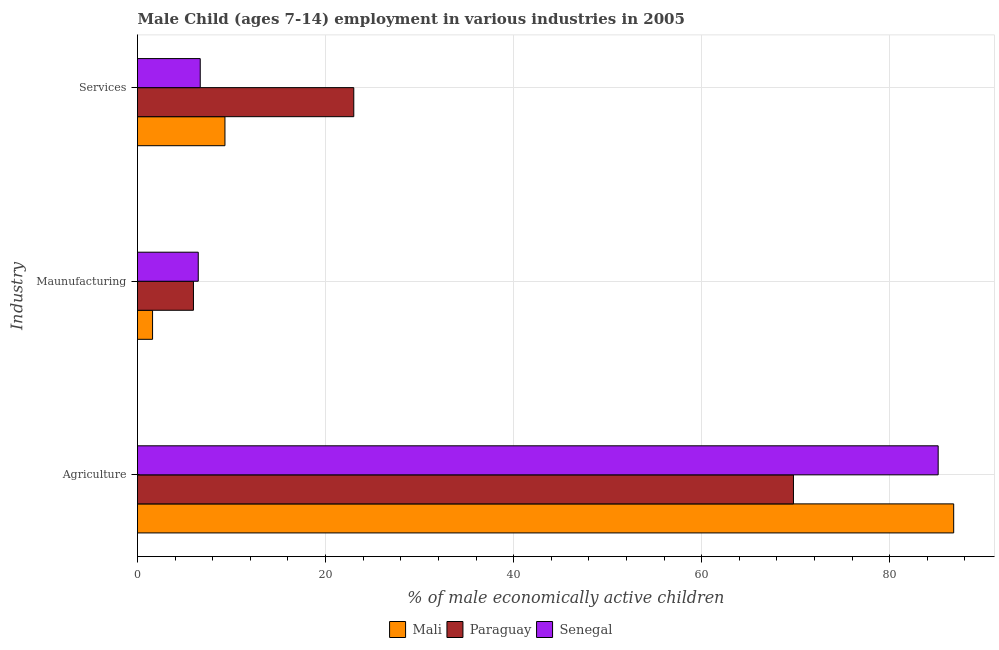Are the number of bars on each tick of the Y-axis equal?
Make the answer very short. Yes. How many bars are there on the 1st tick from the bottom?
Your answer should be compact. 3. What is the label of the 3rd group of bars from the top?
Keep it short and to the point. Agriculture. What is the percentage of economically active children in agriculture in Paraguay?
Your answer should be very brief. 69.76. Across all countries, what is the maximum percentage of economically active children in manufacturing?
Offer a very short reply. 6.46. Across all countries, what is the minimum percentage of economically active children in manufacturing?
Give a very brief answer. 1.6. In which country was the percentage of economically active children in services maximum?
Provide a succinct answer. Paraguay. In which country was the percentage of economically active children in services minimum?
Provide a short and direct response. Senegal. What is the total percentage of economically active children in agriculture in the graph?
Provide a succinct answer. 241.71. What is the difference between the percentage of economically active children in services in Mali and that in Paraguay?
Make the answer very short. -13.7. What is the difference between the percentage of economically active children in services in Mali and the percentage of economically active children in agriculture in Senegal?
Your response must be concise. -75.85. What is the average percentage of economically active children in agriculture per country?
Provide a succinct answer. 80.57. What is the difference between the percentage of economically active children in manufacturing and percentage of economically active children in services in Senegal?
Offer a terse response. -0.21. In how many countries, is the percentage of economically active children in manufacturing greater than 16 %?
Your answer should be compact. 0. What is the ratio of the percentage of economically active children in manufacturing in Senegal to that in Paraguay?
Your response must be concise. 1.09. Is the difference between the percentage of economically active children in services in Senegal and Mali greater than the difference between the percentage of economically active children in agriculture in Senegal and Mali?
Provide a short and direct response. No. What is the difference between the highest and the second highest percentage of economically active children in manufacturing?
Your answer should be very brief. 0.51. What is the difference between the highest and the lowest percentage of economically active children in agriculture?
Offer a very short reply. 17.04. In how many countries, is the percentage of economically active children in agriculture greater than the average percentage of economically active children in agriculture taken over all countries?
Your answer should be very brief. 2. What does the 3rd bar from the top in Services represents?
Provide a succinct answer. Mali. What does the 1st bar from the bottom in Agriculture represents?
Give a very brief answer. Mali. How many bars are there?
Your answer should be compact. 9. How many countries are there in the graph?
Ensure brevity in your answer.  3. How are the legend labels stacked?
Offer a very short reply. Horizontal. What is the title of the graph?
Your answer should be very brief. Male Child (ages 7-14) employment in various industries in 2005. What is the label or title of the X-axis?
Offer a terse response. % of male economically active children. What is the label or title of the Y-axis?
Your response must be concise. Industry. What is the % of male economically active children of Mali in Agriculture?
Your response must be concise. 86.8. What is the % of male economically active children of Paraguay in Agriculture?
Offer a very short reply. 69.76. What is the % of male economically active children of Senegal in Agriculture?
Provide a short and direct response. 85.15. What is the % of male economically active children in Mali in Maunufacturing?
Your answer should be very brief. 1.6. What is the % of male economically active children of Paraguay in Maunufacturing?
Give a very brief answer. 5.95. What is the % of male economically active children of Senegal in Maunufacturing?
Your answer should be very brief. 6.46. What is the % of male economically active children of Mali in Services?
Your answer should be compact. 9.3. What is the % of male economically active children in Paraguay in Services?
Offer a terse response. 23. What is the % of male economically active children in Senegal in Services?
Your answer should be very brief. 6.67. Across all Industry, what is the maximum % of male economically active children of Mali?
Your answer should be very brief. 86.8. Across all Industry, what is the maximum % of male economically active children in Paraguay?
Provide a short and direct response. 69.76. Across all Industry, what is the maximum % of male economically active children of Senegal?
Provide a short and direct response. 85.15. Across all Industry, what is the minimum % of male economically active children of Paraguay?
Provide a short and direct response. 5.95. Across all Industry, what is the minimum % of male economically active children of Senegal?
Give a very brief answer. 6.46. What is the total % of male economically active children of Mali in the graph?
Offer a very short reply. 97.7. What is the total % of male economically active children in Paraguay in the graph?
Your answer should be compact. 98.71. What is the total % of male economically active children in Senegal in the graph?
Provide a succinct answer. 98.28. What is the difference between the % of male economically active children of Mali in Agriculture and that in Maunufacturing?
Provide a succinct answer. 85.2. What is the difference between the % of male economically active children in Paraguay in Agriculture and that in Maunufacturing?
Provide a short and direct response. 63.81. What is the difference between the % of male economically active children of Senegal in Agriculture and that in Maunufacturing?
Your answer should be very brief. 78.69. What is the difference between the % of male economically active children of Mali in Agriculture and that in Services?
Make the answer very short. 77.5. What is the difference between the % of male economically active children of Paraguay in Agriculture and that in Services?
Make the answer very short. 46.76. What is the difference between the % of male economically active children of Senegal in Agriculture and that in Services?
Make the answer very short. 78.48. What is the difference between the % of male economically active children of Paraguay in Maunufacturing and that in Services?
Offer a very short reply. -17.05. What is the difference between the % of male economically active children of Senegal in Maunufacturing and that in Services?
Offer a terse response. -0.21. What is the difference between the % of male economically active children of Mali in Agriculture and the % of male economically active children of Paraguay in Maunufacturing?
Offer a very short reply. 80.85. What is the difference between the % of male economically active children of Mali in Agriculture and the % of male economically active children of Senegal in Maunufacturing?
Give a very brief answer. 80.34. What is the difference between the % of male economically active children in Paraguay in Agriculture and the % of male economically active children in Senegal in Maunufacturing?
Make the answer very short. 63.3. What is the difference between the % of male economically active children of Mali in Agriculture and the % of male economically active children of Paraguay in Services?
Give a very brief answer. 63.8. What is the difference between the % of male economically active children of Mali in Agriculture and the % of male economically active children of Senegal in Services?
Keep it short and to the point. 80.13. What is the difference between the % of male economically active children of Paraguay in Agriculture and the % of male economically active children of Senegal in Services?
Your answer should be very brief. 63.09. What is the difference between the % of male economically active children of Mali in Maunufacturing and the % of male economically active children of Paraguay in Services?
Provide a succinct answer. -21.4. What is the difference between the % of male economically active children in Mali in Maunufacturing and the % of male economically active children in Senegal in Services?
Keep it short and to the point. -5.07. What is the difference between the % of male economically active children in Paraguay in Maunufacturing and the % of male economically active children in Senegal in Services?
Ensure brevity in your answer.  -0.72. What is the average % of male economically active children in Mali per Industry?
Give a very brief answer. 32.57. What is the average % of male economically active children of Paraguay per Industry?
Provide a short and direct response. 32.9. What is the average % of male economically active children in Senegal per Industry?
Ensure brevity in your answer.  32.76. What is the difference between the % of male economically active children in Mali and % of male economically active children in Paraguay in Agriculture?
Offer a very short reply. 17.04. What is the difference between the % of male economically active children of Mali and % of male economically active children of Senegal in Agriculture?
Provide a succinct answer. 1.65. What is the difference between the % of male economically active children in Paraguay and % of male economically active children in Senegal in Agriculture?
Provide a succinct answer. -15.39. What is the difference between the % of male economically active children of Mali and % of male economically active children of Paraguay in Maunufacturing?
Make the answer very short. -4.35. What is the difference between the % of male economically active children in Mali and % of male economically active children in Senegal in Maunufacturing?
Your answer should be very brief. -4.86. What is the difference between the % of male economically active children of Paraguay and % of male economically active children of Senegal in Maunufacturing?
Make the answer very short. -0.51. What is the difference between the % of male economically active children in Mali and % of male economically active children in Paraguay in Services?
Provide a succinct answer. -13.7. What is the difference between the % of male economically active children of Mali and % of male economically active children of Senegal in Services?
Provide a succinct answer. 2.63. What is the difference between the % of male economically active children in Paraguay and % of male economically active children in Senegal in Services?
Your response must be concise. 16.33. What is the ratio of the % of male economically active children of Mali in Agriculture to that in Maunufacturing?
Offer a terse response. 54.25. What is the ratio of the % of male economically active children of Paraguay in Agriculture to that in Maunufacturing?
Offer a terse response. 11.72. What is the ratio of the % of male economically active children in Senegal in Agriculture to that in Maunufacturing?
Make the answer very short. 13.18. What is the ratio of the % of male economically active children of Mali in Agriculture to that in Services?
Your answer should be compact. 9.33. What is the ratio of the % of male economically active children in Paraguay in Agriculture to that in Services?
Make the answer very short. 3.03. What is the ratio of the % of male economically active children in Senegal in Agriculture to that in Services?
Keep it short and to the point. 12.77. What is the ratio of the % of male economically active children of Mali in Maunufacturing to that in Services?
Ensure brevity in your answer.  0.17. What is the ratio of the % of male economically active children of Paraguay in Maunufacturing to that in Services?
Your answer should be very brief. 0.26. What is the ratio of the % of male economically active children of Senegal in Maunufacturing to that in Services?
Give a very brief answer. 0.97. What is the difference between the highest and the second highest % of male economically active children in Mali?
Offer a very short reply. 77.5. What is the difference between the highest and the second highest % of male economically active children in Paraguay?
Provide a succinct answer. 46.76. What is the difference between the highest and the second highest % of male economically active children in Senegal?
Offer a very short reply. 78.48. What is the difference between the highest and the lowest % of male economically active children in Mali?
Give a very brief answer. 85.2. What is the difference between the highest and the lowest % of male economically active children of Paraguay?
Keep it short and to the point. 63.81. What is the difference between the highest and the lowest % of male economically active children in Senegal?
Give a very brief answer. 78.69. 